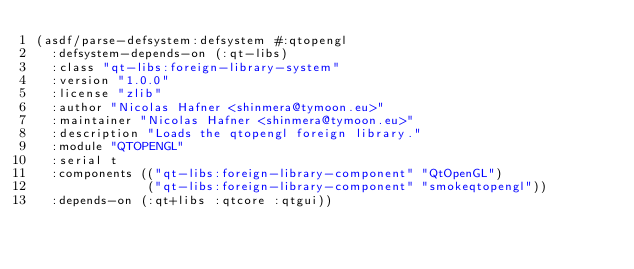Convert code to text. <code><loc_0><loc_0><loc_500><loc_500><_Lisp_>(asdf/parse-defsystem:defsystem #:qtopengl
  :defsystem-depends-on (:qt-libs)
  :class "qt-libs:foreign-library-system"
  :version "1.0.0"
  :license "zlib"
  :author "Nicolas Hafner <shinmera@tymoon.eu>"
  :maintainer "Nicolas Hafner <shinmera@tymoon.eu>"
  :description "Loads the qtopengl foreign library."
  :module "QTOPENGL"
  :serial t
  :components (("qt-libs:foreign-library-component" "QtOpenGL")
               ("qt-libs:foreign-library-component" "smokeqtopengl"))
  :depends-on (:qt+libs :qtcore :qtgui))</code> 